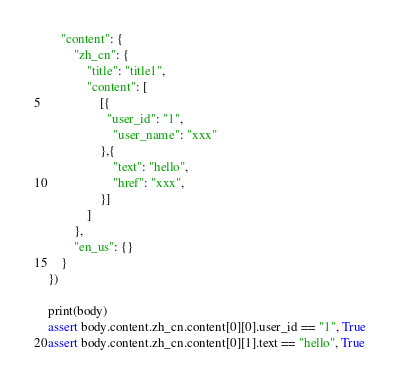Convert code to text. <code><loc_0><loc_0><loc_500><loc_500><_Python_>    "content": {
        "zh_cn": {
            "title": "title1",
            "content": [
                [{
                  "user_id": "1",
                    "user_name": "xxx"
                },{
                    "text": "hello",
                    "href": "xxx",
                }]
            ]
        },
        "en_us": {}
    }
})

print(body)
assert body.content.zh_cn.content[0][0].user_id == "1", True
assert body.content.zh_cn.content[0][1].text == "hello", True</code> 